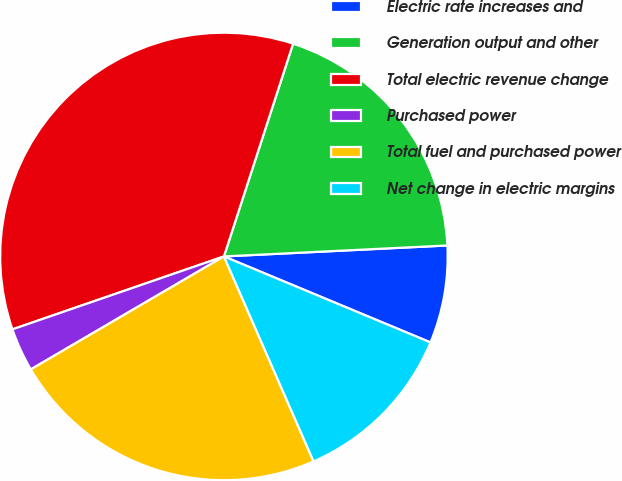Convert chart. <chart><loc_0><loc_0><loc_500><loc_500><pie_chart><fcel>Electric rate increases and<fcel>Generation output and other<fcel>Total electric revenue change<fcel>Purchased power<fcel>Total fuel and purchased power<fcel>Net change in electric margins<nl><fcel>7.06%<fcel>19.22%<fcel>35.29%<fcel>3.14%<fcel>23.14%<fcel>12.16%<nl></chart> 